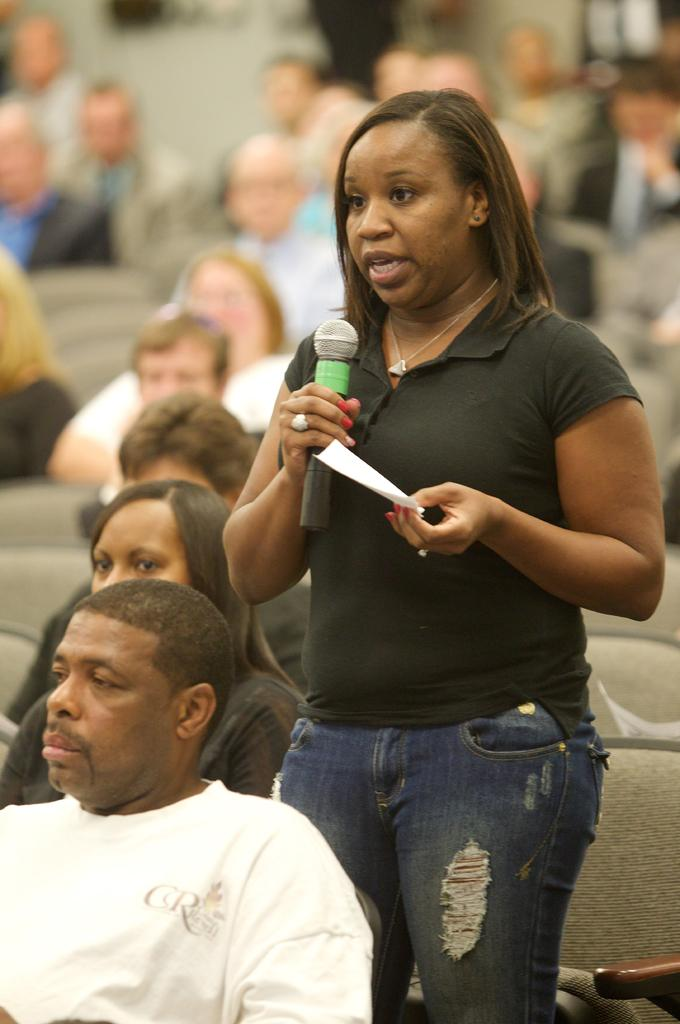What is the main activity of the people in the image? The people in the image are sitting on chairs. Is there anyone standing in the image? Yes, one woman is standing in the image. What is the woman holding in her hands? The woman is holding a paper and a microphone. Can you tell me how many kittens are sitting on the chairs in the image? There are no kittens present in the image; it features a group of people sitting on chairs. What type of reading material is the woman holding in the image? The woman is holding a paper, but there is no indication of the content or type of reading material. 